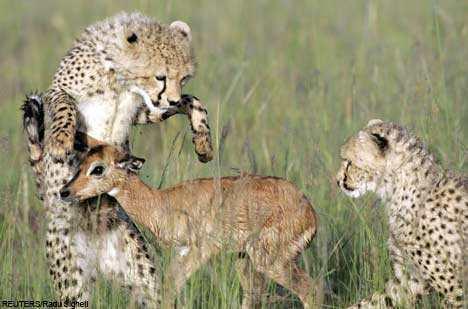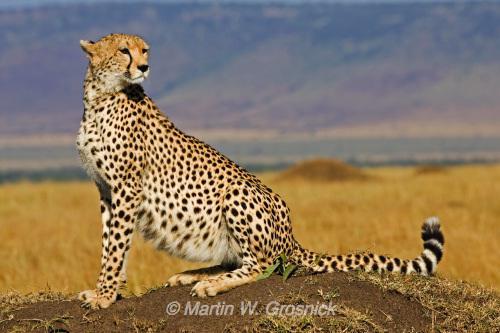The first image is the image on the left, the second image is the image on the right. Examine the images to the left and right. Is the description "An image shows two same-sized similarly-posed spotted cats with their heads close together." accurate? Answer yes or no. No. The first image is the image on the left, the second image is the image on the right. For the images shown, is this caption "The left image contains at least two cheetahs." true? Answer yes or no. Yes. 